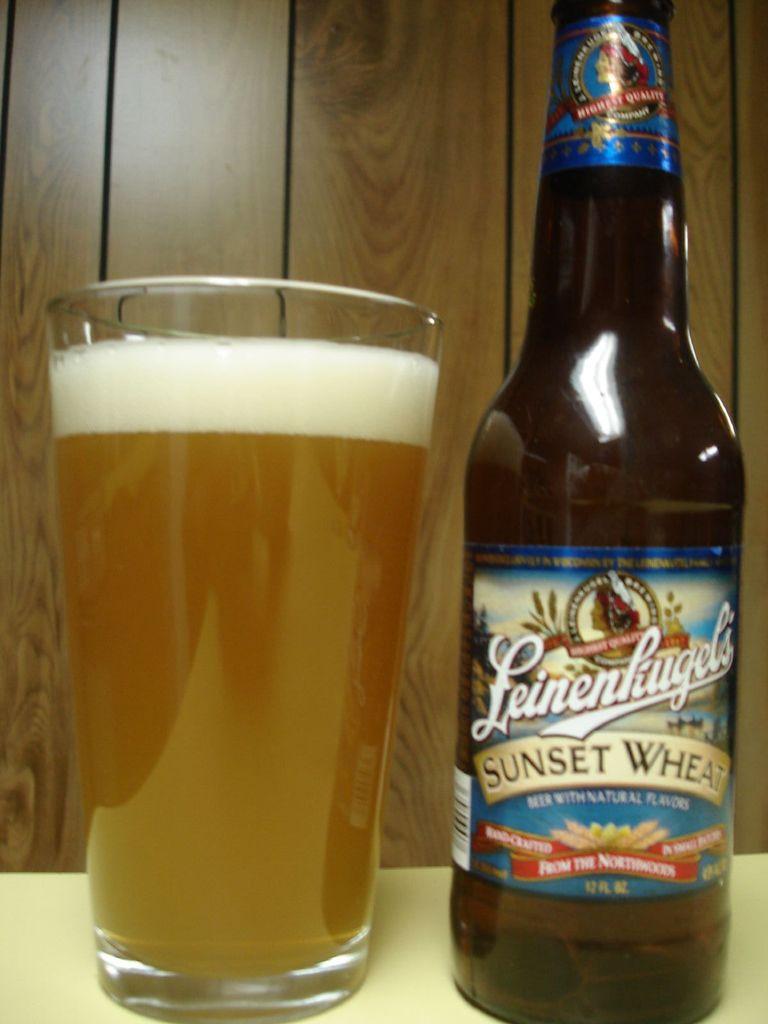What is this superior style of beer, named after the plant it is derived from?
Provide a succinct answer. Sunset wheat. 